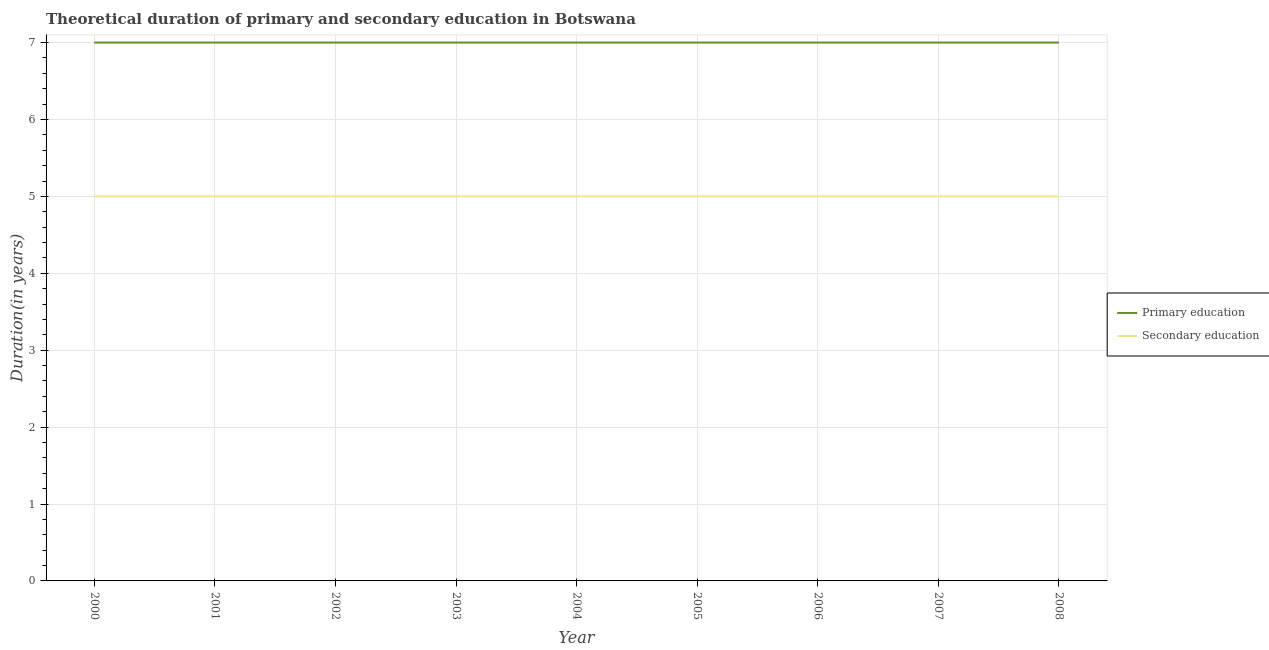Is the number of lines equal to the number of legend labels?
Make the answer very short. Yes. What is the duration of primary education in 2008?
Your answer should be compact. 7. Across all years, what is the maximum duration of secondary education?
Provide a succinct answer. 5. Across all years, what is the minimum duration of secondary education?
Provide a short and direct response. 5. What is the total duration of secondary education in the graph?
Make the answer very short. 45. What is the difference between the duration of primary education in 2005 and the duration of secondary education in 2007?
Your answer should be very brief. 2. What is the average duration of primary education per year?
Offer a very short reply. 7. In the year 2006, what is the difference between the duration of secondary education and duration of primary education?
Offer a very short reply. -2. In how many years, is the duration of secondary education greater than 3.6 years?
Your response must be concise. 9. What is the ratio of the duration of primary education in 2000 to that in 2003?
Your answer should be compact. 1. Is the difference between the duration of primary education in 2005 and 2008 greater than the difference between the duration of secondary education in 2005 and 2008?
Ensure brevity in your answer.  No. In how many years, is the duration of secondary education greater than the average duration of secondary education taken over all years?
Keep it short and to the point. 0. Does the duration of secondary education monotonically increase over the years?
Offer a very short reply. No. Is the duration of secondary education strictly less than the duration of primary education over the years?
Your answer should be very brief. Yes. What is the difference between two consecutive major ticks on the Y-axis?
Offer a very short reply. 1. Are the values on the major ticks of Y-axis written in scientific E-notation?
Your response must be concise. No. Does the graph contain any zero values?
Keep it short and to the point. No. Does the graph contain grids?
Make the answer very short. Yes. How many legend labels are there?
Give a very brief answer. 2. What is the title of the graph?
Ensure brevity in your answer.  Theoretical duration of primary and secondary education in Botswana. What is the label or title of the X-axis?
Keep it short and to the point. Year. What is the label or title of the Y-axis?
Give a very brief answer. Duration(in years). What is the Duration(in years) of Secondary education in 2000?
Give a very brief answer. 5. What is the Duration(in years) of Primary education in 2001?
Keep it short and to the point. 7. What is the Duration(in years) of Primary education in 2002?
Make the answer very short. 7. What is the Duration(in years) in Secondary education in 2002?
Provide a succinct answer. 5. What is the Duration(in years) of Secondary education in 2004?
Your answer should be very brief. 5. What is the Duration(in years) in Secondary education in 2007?
Your answer should be compact. 5. Across all years, what is the minimum Duration(in years) of Primary education?
Make the answer very short. 7. Across all years, what is the minimum Duration(in years) in Secondary education?
Keep it short and to the point. 5. What is the difference between the Duration(in years) of Secondary education in 2000 and that in 2002?
Your answer should be very brief. 0. What is the difference between the Duration(in years) of Primary education in 2000 and that in 2003?
Make the answer very short. 0. What is the difference between the Duration(in years) of Primary education in 2000 and that in 2005?
Your response must be concise. 0. What is the difference between the Duration(in years) in Secondary education in 2000 and that in 2005?
Offer a very short reply. 0. What is the difference between the Duration(in years) of Primary education in 2000 and that in 2006?
Keep it short and to the point. 0. What is the difference between the Duration(in years) of Secondary education in 2000 and that in 2006?
Offer a very short reply. 0. What is the difference between the Duration(in years) in Secondary education in 2000 and that in 2008?
Offer a very short reply. 0. What is the difference between the Duration(in years) of Secondary education in 2001 and that in 2002?
Your response must be concise. 0. What is the difference between the Duration(in years) in Primary education in 2001 and that in 2003?
Your answer should be very brief. 0. What is the difference between the Duration(in years) of Secondary education in 2001 and that in 2003?
Your response must be concise. 0. What is the difference between the Duration(in years) of Primary education in 2001 and that in 2005?
Make the answer very short. 0. What is the difference between the Duration(in years) of Secondary education in 2001 and that in 2005?
Your answer should be compact. 0. What is the difference between the Duration(in years) of Primary education in 2001 and that in 2006?
Your answer should be very brief. 0. What is the difference between the Duration(in years) in Primary education in 2001 and that in 2007?
Ensure brevity in your answer.  0. What is the difference between the Duration(in years) in Secondary education in 2002 and that in 2003?
Your response must be concise. 0. What is the difference between the Duration(in years) in Primary education in 2002 and that in 2004?
Provide a succinct answer. 0. What is the difference between the Duration(in years) in Secondary education in 2002 and that in 2007?
Make the answer very short. 0. What is the difference between the Duration(in years) in Secondary education in 2002 and that in 2008?
Keep it short and to the point. 0. What is the difference between the Duration(in years) of Primary education in 2003 and that in 2005?
Provide a short and direct response. 0. What is the difference between the Duration(in years) of Secondary education in 2003 and that in 2005?
Provide a succinct answer. 0. What is the difference between the Duration(in years) of Primary education in 2003 and that in 2006?
Give a very brief answer. 0. What is the difference between the Duration(in years) of Secondary education in 2003 and that in 2007?
Make the answer very short. 0. What is the difference between the Duration(in years) in Primary education in 2003 and that in 2008?
Provide a short and direct response. 0. What is the difference between the Duration(in years) in Secondary education in 2003 and that in 2008?
Provide a short and direct response. 0. What is the difference between the Duration(in years) in Primary education in 2004 and that in 2005?
Provide a short and direct response. 0. What is the difference between the Duration(in years) in Primary education in 2004 and that in 2007?
Make the answer very short. 0. What is the difference between the Duration(in years) of Primary education in 2004 and that in 2008?
Give a very brief answer. 0. What is the difference between the Duration(in years) in Secondary education in 2004 and that in 2008?
Your answer should be very brief. 0. What is the difference between the Duration(in years) of Primary education in 2005 and that in 2006?
Your answer should be compact. 0. What is the difference between the Duration(in years) in Secondary education in 2005 and that in 2006?
Your answer should be very brief. 0. What is the difference between the Duration(in years) of Primary education in 2006 and that in 2007?
Provide a succinct answer. 0. What is the difference between the Duration(in years) in Secondary education in 2006 and that in 2007?
Ensure brevity in your answer.  0. What is the difference between the Duration(in years) of Secondary education in 2006 and that in 2008?
Your response must be concise. 0. What is the difference between the Duration(in years) of Primary education in 2007 and that in 2008?
Offer a terse response. 0. What is the difference between the Duration(in years) of Primary education in 2000 and the Duration(in years) of Secondary education in 2006?
Provide a succinct answer. 2. What is the difference between the Duration(in years) of Primary education in 2000 and the Duration(in years) of Secondary education in 2008?
Offer a terse response. 2. What is the difference between the Duration(in years) of Primary education in 2001 and the Duration(in years) of Secondary education in 2004?
Keep it short and to the point. 2. What is the difference between the Duration(in years) in Primary education in 2001 and the Duration(in years) in Secondary education in 2006?
Offer a very short reply. 2. What is the difference between the Duration(in years) in Primary education in 2002 and the Duration(in years) in Secondary education in 2005?
Your answer should be compact. 2. What is the difference between the Duration(in years) of Primary education in 2002 and the Duration(in years) of Secondary education in 2006?
Provide a succinct answer. 2. What is the difference between the Duration(in years) in Primary education in 2002 and the Duration(in years) in Secondary education in 2007?
Give a very brief answer. 2. What is the difference between the Duration(in years) of Primary education in 2002 and the Duration(in years) of Secondary education in 2008?
Keep it short and to the point. 2. What is the difference between the Duration(in years) of Primary education in 2003 and the Duration(in years) of Secondary education in 2006?
Provide a succinct answer. 2. What is the difference between the Duration(in years) in Primary education in 2003 and the Duration(in years) in Secondary education in 2008?
Make the answer very short. 2. What is the difference between the Duration(in years) in Primary education in 2004 and the Duration(in years) in Secondary education in 2005?
Your response must be concise. 2. What is the difference between the Duration(in years) of Primary education in 2004 and the Duration(in years) of Secondary education in 2007?
Offer a very short reply. 2. What is the difference between the Duration(in years) in Primary education in 2005 and the Duration(in years) in Secondary education in 2007?
Give a very brief answer. 2. What is the difference between the Duration(in years) of Primary education in 2006 and the Duration(in years) of Secondary education in 2007?
Offer a terse response. 2. What is the average Duration(in years) of Primary education per year?
Provide a succinct answer. 7. In the year 2000, what is the difference between the Duration(in years) of Primary education and Duration(in years) of Secondary education?
Keep it short and to the point. 2. In the year 2005, what is the difference between the Duration(in years) in Primary education and Duration(in years) in Secondary education?
Offer a terse response. 2. In the year 2007, what is the difference between the Duration(in years) of Primary education and Duration(in years) of Secondary education?
Your answer should be compact. 2. In the year 2008, what is the difference between the Duration(in years) in Primary education and Duration(in years) in Secondary education?
Give a very brief answer. 2. What is the ratio of the Duration(in years) of Secondary education in 2000 to that in 2001?
Make the answer very short. 1. What is the ratio of the Duration(in years) of Primary education in 2000 to that in 2002?
Your answer should be compact. 1. What is the ratio of the Duration(in years) in Secondary education in 2000 to that in 2002?
Your answer should be compact. 1. What is the ratio of the Duration(in years) in Primary education in 2000 to that in 2003?
Provide a short and direct response. 1. What is the ratio of the Duration(in years) of Primary education in 2000 to that in 2004?
Your answer should be very brief. 1. What is the ratio of the Duration(in years) of Secondary education in 2000 to that in 2005?
Make the answer very short. 1. What is the ratio of the Duration(in years) in Secondary education in 2000 to that in 2007?
Offer a terse response. 1. What is the ratio of the Duration(in years) in Secondary education in 2000 to that in 2008?
Keep it short and to the point. 1. What is the ratio of the Duration(in years) in Primary education in 2001 to that in 2002?
Provide a short and direct response. 1. What is the ratio of the Duration(in years) in Secondary education in 2001 to that in 2003?
Ensure brevity in your answer.  1. What is the ratio of the Duration(in years) in Primary education in 2001 to that in 2004?
Keep it short and to the point. 1. What is the ratio of the Duration(in years) in Secondary education in 2001 to that in 2004?
Provide a short and direct response. 1. What is the ratio of the Duration(in years) in Secondary education in 2001 to that in 2005?
Offer a terse response. 1. What is the ratio of the Duration(in years) of Primary education in 2001 to that in 2007?
Make the answer very short. 1. What is the ratio of the Duration(in years) of Primary education in 2002 to that in 2004?
Give a very brief answer. 1. What is the ratio of the Duration(in years) in Secondary education in 2002 to that in 2005?
Keep it short and to the point. 1. What is the ratio of the Duration(in years) in Secondary education in 2002 to that in 2006?
Provide a short and direct response. 1. What is the ratio of the Duration(in years) of Primary education in 2002 to that in 2007?
Keep it short and to the point. 1. What is the ratio of the Duration(in years) in Primary education in 2003 to that in 2004?
Give a very brief answer. 1. What is the ratio of the Duration(in years) in Secondary education in 2003 to that in 2004?
Your answer should be compact. 1. What is the ratio of the Duration(in years) of Secondary education in 2003 to that in 2006?
Offer a very short reply. 1. What is the ratio of the Duration(in years) of Primary education in 2003 to that in 2007?
Ensure brevity in your answer.  1. What is the ratio of the Duration(in years) of Primary education in 2003 to that in 2008?
Ensure brevity in your answer.  1. What is the ratio of the Duration(in years) in Secondary education in 2003 to that in 2008?
Your answer should be very brief. 1. What is the ratio of the Duration(in years) of Primary education in 2004 to that in 2006?
Offer a terse response. 1. What is the ratio of the Duration(in years) of Primary education in 2004 to that in 2007?
Make the answer very short. 1. What is the ratio of the Duration(in years) in Secondary education in 2004 to that in 2007?
Offer a terse response. 1. What is the ratio of the Duration(in years) of Secondary education in 2005 to that in 2006?
Make the answer very short. 1. What is the ratio of the Duration(in years) in Primary education in 2005 to that in 2007?
Your response must be concise. 1. What is the ratio of the Duration(in years) of Primary education in 2005 to that in 2008?
Ensure brevity in your answer.  1. What is the ratio of the Duration(in years) of Secondary education in 2005 to that in 2008?
Your response must be concise. 1. What is the ratio of the Duration(in years) in Primary education in 2006 to that in 2008?
Your response must be concise. 1. What is the ratio of the Duration(in years) of Primary education in 2007 to that in 2008?
Provide a short and direct response. 1. What is the ratio of the Duration(in years) of Secondary education in 2007 to that in 2008?
Give a very brief answer. 1. What is the difference between the highest and the lowest Duration(in years) of Secondary education?
Provide a short and direct response. 0. 